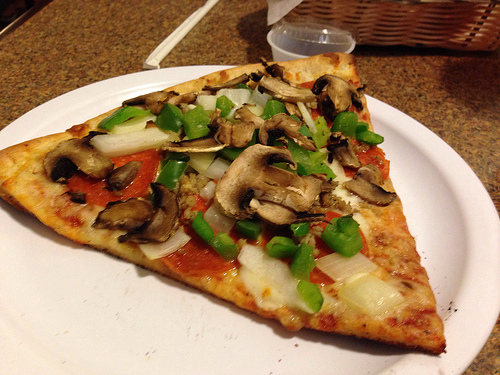Please provide a short description for this region: [0.51, 0.13, 0.96, 0.28]. This part of the image shows a brown basket situated next to a plastic container. 